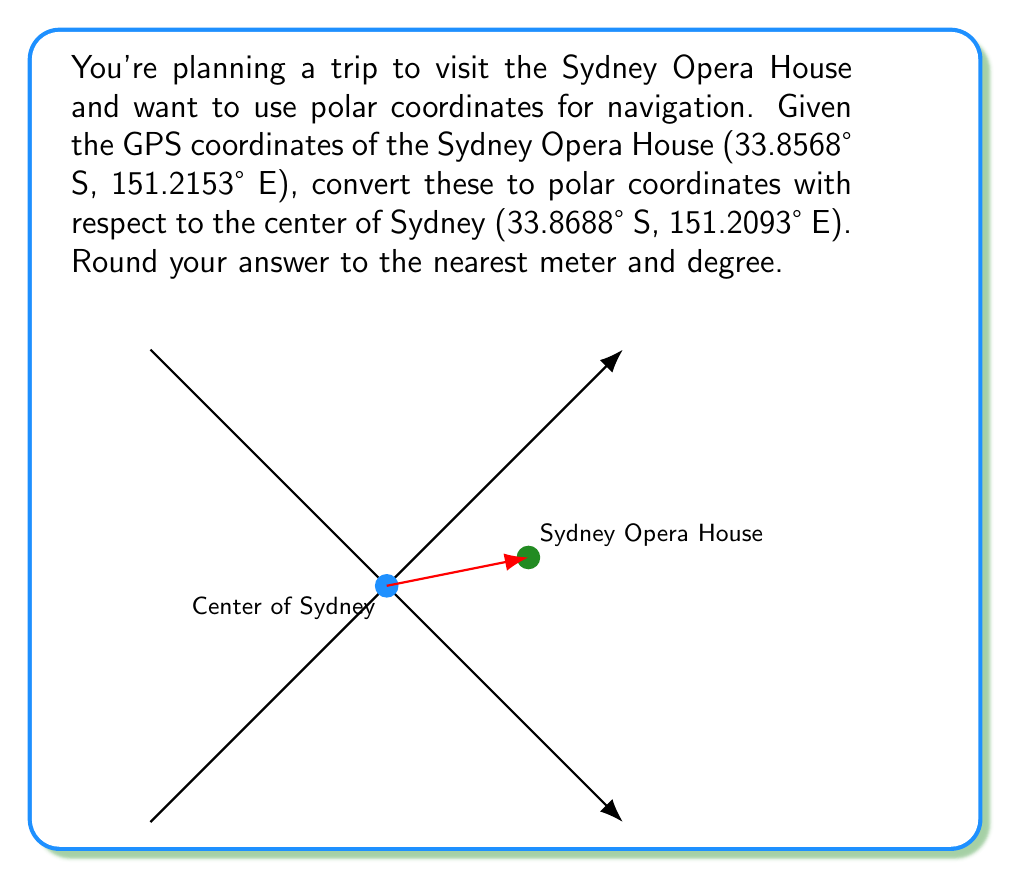Give your solution to this math problem. To convert GPS coordinates to polar form, we need to:

1. Convert the latitude and longitude differences to distances in meters.
2. Calculate the distance (r) using the Pythagorean theorem.
3. Calculate the angle (θ) using the arctangent function.

Step 1: Convert coordinate differences to meters
Latitude difference: $\Delta\text{lat} = 33.8688° - 33.8568° = 0.012°$
Longitude difference: $\Delta\text{lon} = 151.2153° - 151.2093° = 0.006°$

1° of latitude ≈ 111,000 meters
1° of longitude at 33.86° S ≈ 92,000 meters

$\Delta y = 0.012° \times 111,000 \text{ m/°} = 1,332 \text{ m}$
$\Delta x = 0.006° \times 92,000 \text{ m/°} = 552 \text{ m}$

Step 2: Calculate distance (r)
$$r = \sqrt{(\Delta x)^2 + (\Delta y)^2} = \sqrt{552^2 + 1332^2} \approx 1,442.8 \text{ m}$$

Step 3: Calculate angle (θ)
$$\theta = \arctan\left(\frac{\Delta y}{\Delta x}\right) = \arctan\left(\frac{1332}{552}\right) \approx 67.5°$$

Convert to standard polar form (measured counterclockwise from east):
$$\theta_{\text{standard}} = 90° - 67.5° = 22.5°$$
Answer: $(1443 \text{ m}, 22.5°)$ 